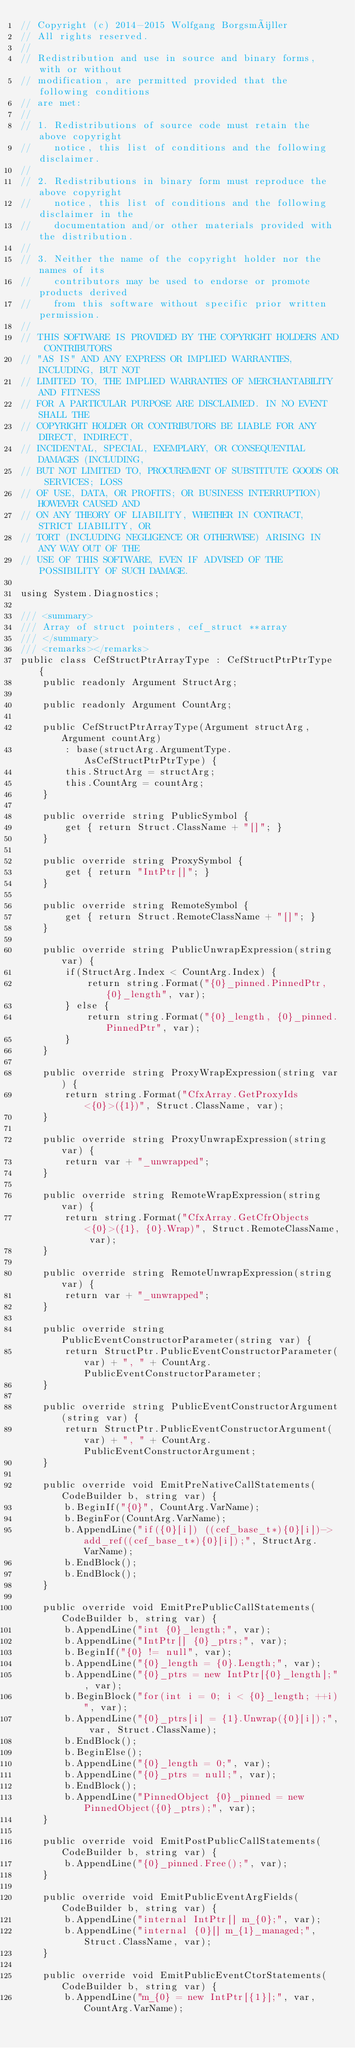<code> <loc_0><loc_0><loc_500><loc_500><_C#_>// Copyright (c) 2014-2015 Wolfgang Borgsmüller
// All rights reserved.
// 
// Redistribution and use in source and binary forms, with or without 
// modification, are permitted provided that the following conditions 
// are met:
// 
// 1. Redistributions of source code must retain the above copyright 
//    notice, this list of conditions and the following disclaimer.
// 
// 2. Redistributions in binary form must reproduce the above copyright 
//    notice, this list of conditions and the following disclaimer in the 
//    documentation and/or other materials provided with the distribution.
// 
// 3. Neither the name of the copyright holder nor the names of its 
//    contributors may be used to endorse or promote products derived 
//    from this software without specific prior written permission.
// 
// THIS SOFTWARE IS PROVIDED BY THE COPYRIGHT HOLDERS AND CONTRIBUTORS 
// "AS IS" AND ANY EXPRESS OR IMPLIED WARRANTIES, INCLUDING, BUT NOT 
// LIMITED TO, THE IMPLIED WARRANTIES OF MERCHANTABILITY AND FITNESS 
// FOR A PARTICULAR PURPOSE ARE DISCLAIMED. IN NO EVENT SHALL THE 
// COPYRIGHT HOLDER OR CONTRIBUTORS BE LIABLE FOR ANY DIRECT, INDIRECT, 
// INCIDENTAL, SPECIAL, EXEMPLARY, OR CONSEQUENTIAL DAMAGES (INCLUDING, 
// BUT NOT LIMITED TO, PROCUREMENT OF SUBSTITUTE GOODS OR SERVICES; LOSS 
// OF USE, DATA, OR PROFITS; OR BUSINESS INTERRUPTION) HOWEVER CAUSED AND 
// ON ANY THEORY OF LIABILITY, WHETHER IN CONTRACT, STRICT LIABILITY, OR 
// TORT (INCLUDING NEGLIGENCE OR OTHERWISE) ARISING IN ANY WAY OUT OF THE 
// USE OF THIS SOFTWARE, EVEN IF ADVISED OF THE POSSIBILITY OF SUCH DAMAGE.

using System.Diagnostics;

/// <summary>
/// Array of struct pointers, cef_struct **array
/// </summary>
/// <remarks></remarks>
public class CefStructPtrArrayType : CefStructPtrPtrType {
    public readonly Argument StructArg;

    public readonly Argument CountArg;

    public CefStructPtrArrayType(Argument structArg, Argument countArg)
        : base(structArg.ArgumentType.AsCefStructPtrPtrType) {
        this.StructArg = structArg;
        this.CountArg = countArg;
    }

    public override string PublicSymbol {
        get { return Struct.ClassName + "[]"; }
    }

    public override string ProxySymbol {
        get { return "IntPtr[]"; }
    }

    public override string RemoteSymbol {
        get { return Struct.RemoteClassName + "[]"; }
    }

    public override string PublicUnwrapExpression(string var) {
        if(StructArg.Index < CountArg.Index) {
            return string.Format("{0}_pinned.PinnedPtr, {0}_length", var);
        } else {
            return string.Format("{0}_length, {0}_pinned.PinnedPtr", var);
        }
    }

    public override string ProxyWrapExpression(string var) {
        return string.Format("CfxArray.GetProxyIds<{0}>({1})", Struct.ClassName, var);
    }

    public override string ProxyUnwrapExpression(string var) {
        return var + "_unwrapped";
    }

    public override string RemoteWrapExpression(string var) {
        return string.Format("CfxArray.GetCfrObjects<{0}>({1}, {0}.Wrap)", Struct.RemoteClassName, var);
    }

    public override string RemoteUnwrapExpression(string var) {
        return var + "_unwrapped";
    }

    public override string PublicEventConstructorParameter(string var) {
        return StructPtr.PublicEventConstructorParameter(var) + ", " + CountArg.PublicEventConstructorParameter;
    }

    public override string PublicEventConstructorArgument(string var) {
        return StructPtr.PublicEventConstructorArgument(var) + ", " + CountArg.PublicEventConstructorArgument;
    }

    public override void EmitPreNativeCallStatements(CodeBuilder b, string var) {
        b.BeginIf("{0}", CountArg.VarName);
        b.BeginFor(CountArg.VarName);
        b.AppendLine("if({0}[i]) ((cef_base_t*){0}[i])->add_ref((cef_base_t*){0}[i]);", StructArg.VarName);
        b.EndBlock();
        b.EndBlock();
    }

    public override void EmitPrePublicCallStatements(CodeBuilder b, string var) {
        b.AppendLine("int {0}_length;", var);
        b.AppendLine("IntPtr[] {0}_ptrs;", var);
        b.BeginIf("{0} != null", var);
        b.AppendLine("{0}_length = {0}.Length;", var);
        b.AppendLine("{0}_ptrs = new IntPtr[{0}_length];", var);
        b.BeginBlock("for(int i = 0; i < {0}_length; ++i)", var);
        b.AppendLine("{0}_ptrs[i] = {1}.Unwrap({0}[i]);", var, Struct.ClassName);
        b.EndBlock();
        b.BeginElse();
        b.AppendLine("{0}_length = 0;", var);
        b.AppendLine("{0}_ptrs = null;", var);
        b.EndBlock();
        b.AppendLine("PinnedObject {0}_pinned = new PinnedObject({0}_ptrs);", var);
    }

    public override void EmitPostPublicCallStatements(CodeBuilder b, string var) {
        b.AppendLine("{0}_pinned.Free();", var);
    }

    public override void EmitPublicEventArgFields(CodeBuilder b, string var) {
        b.AppendLine("internal IntPtr[] m_{0};", var);
        b.AppendLine("internal {0}[] m_{1}_managed;", Struct.ClassName, var);
    }

    public override void EmitPublicEventCtorStatements(CodeBuilder b, string var) {
        b.AppendLine("m_{0} = new IntPtr[{1}];", var, CountArg.VarName);</code> 